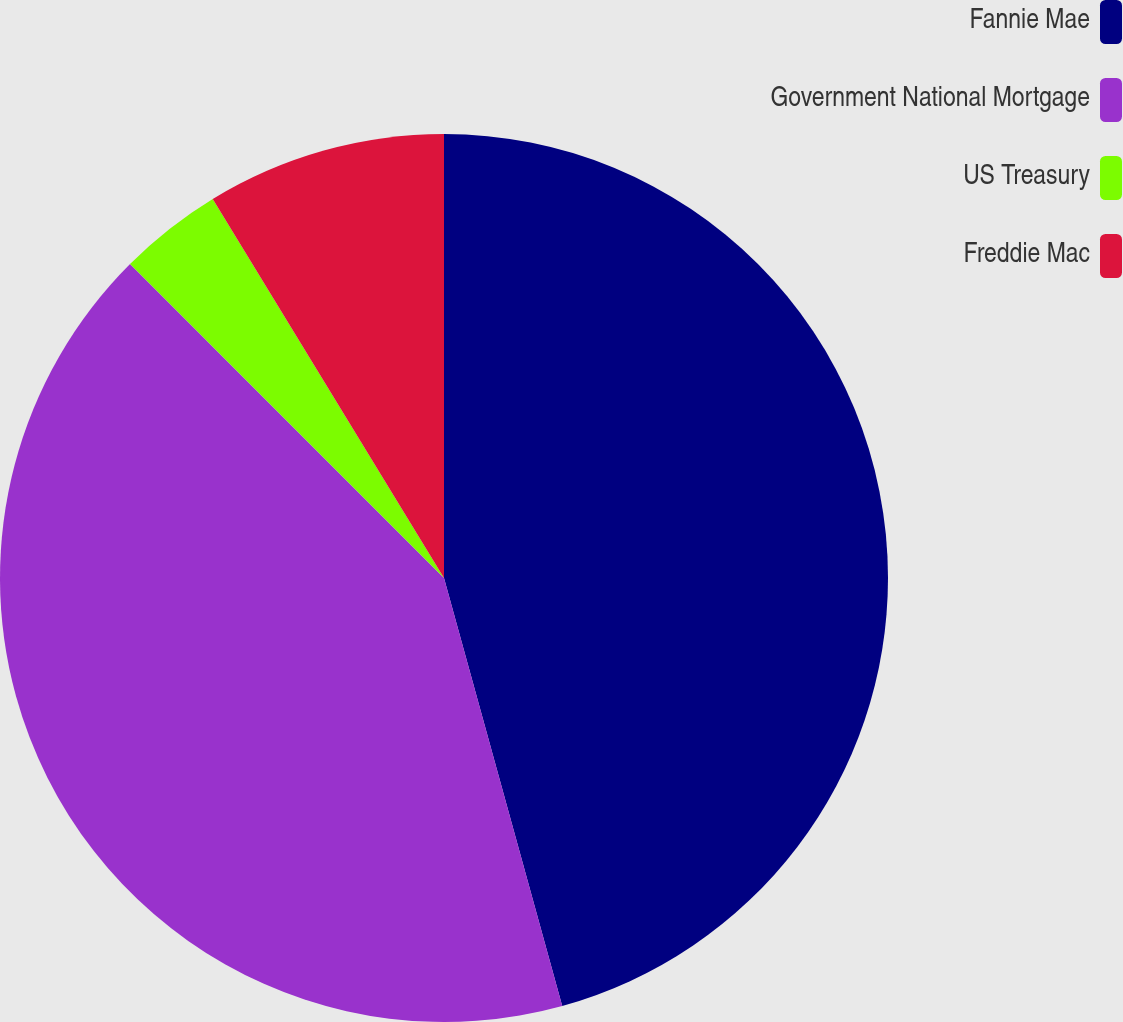Convert chart. <chart><loc_0><loc_0><loc_500><loc_500><pie_chart><fcel>Fannie Mae<fcel>Government National Mortgage<fcel>US Treasury<fcel>Freddie Mac<nl><fcel>45.71%<fcel>41.79%<fcel>3.78%<fcel>8.72%<nl></chart> 